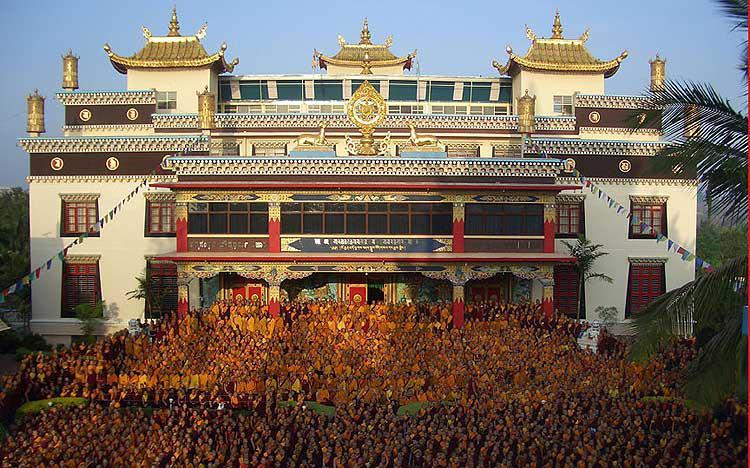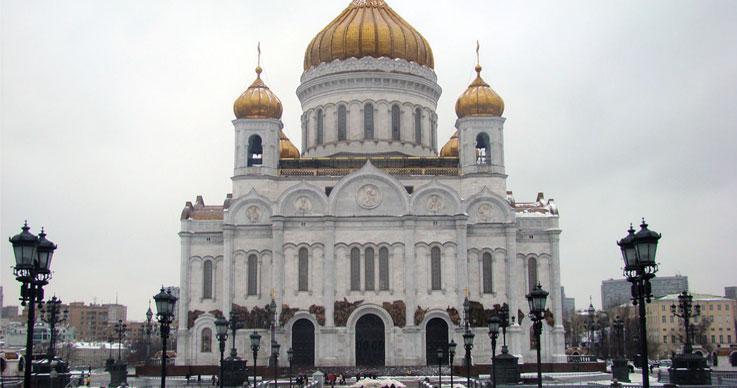The first image is the image on the left, the second image is the image on the right. Analyze the images presented: Is the assertion "An image shows a temple with a line of red-bottomed columns along its front, and an empty lot in front of it." valid? Answer yes or no. No. The first image is the image on the left, the second image is the image on the right. Considering the images on both sides, is "One building has gray stone material, the other does not." valid? Answer yes or no. No. 